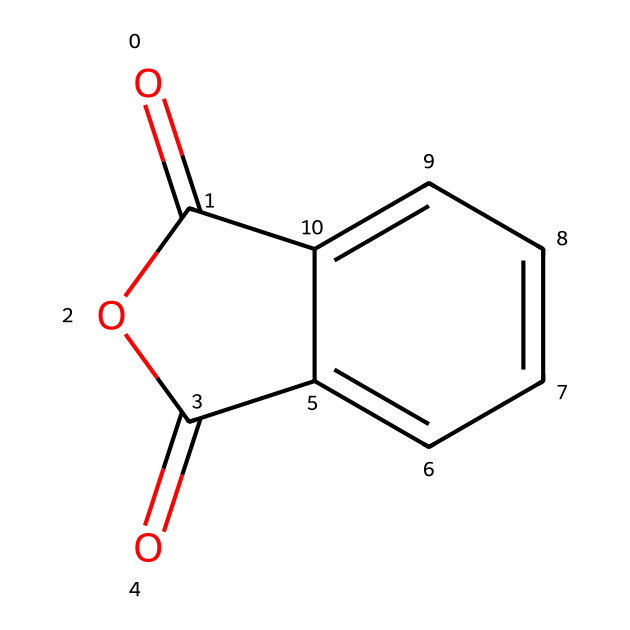What is the IUPAC name of this compound? The structure shows a bicyclic compound with two carboxylate groups linked by an anhydride bond. The systematic IUPAC name for this compound is phthalic anhydride.
Answer: phthalic anhydride How many carbon atoms are present in this structure? The structure consists of a phenyl ring (6 carbon atoms) and an additional 2 carbon atoms from the anhydride part. Adding these gives a total of 8 carbon atoms.
Answer: 8 What type of bond connects the carbonyl groups in the anhydride? The carbonyl groups in phthalic anhydride are connected by an anhydride bond, which is a specific type of bond formed by the removal of water between two carboxylic acid groups.
Answer: anhydride bond What is the total number of oxygen atoms in this compound? Examining the structure shows there are a total of 3 oxygen atoms: one in each carbonyl group and one in the bridging oxygen of the anhydride.
Answer: 3 How does the structure contribute to the use of this compound as a plasticizer? The rigid aromatic rings provide stability while the anhydride groups can interact with polymer chains, enhancing flexibility and processability of plastics, which is typical for plasticizers.
Answer: stability and flexibility Which functional groups are present in this molecule? The molecule contains carbonyl (C=O) and anhydride groups (R–C(=O)–O–C(=O)–R), which are characteristic of phthalic anhydride.
Answer: carbonyl and anhydride groups 